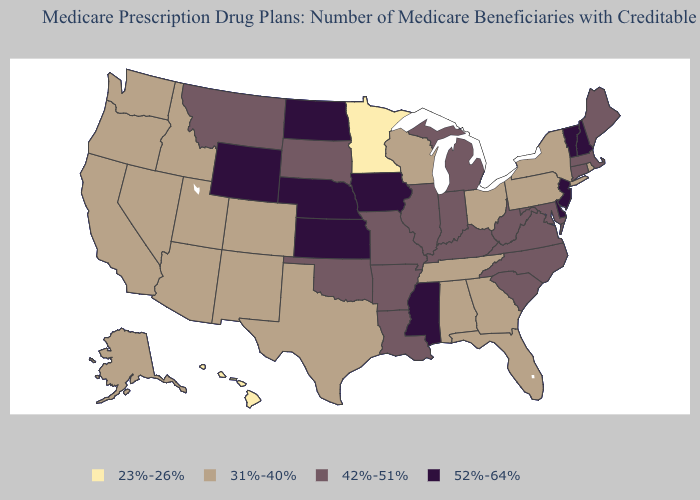Among the states that border Wisconsin , does Illinois have the highest value?
Short answer required. No. Does Michigan have the same value as Colorado?
Answer briefly. No. Name the states that have a value in the range 31%-40%?
Write a very short answer. Alabama, Alaska, Arizona, California, Colorado, Florida, Georgia, Idaho, Nevada, New Mexico, New York, Ohio, Oregon, Pennsylvania, Rhode Island, Tennessee, Texas, Utah, Washington, Wisconsin. Name the states that have a value in the range 42%-51%?
Give a very brief answer. Arkansas, Connecticut, Illinois, Indiana, Kentucky, Louisiana, Maine, Maryland, Massachusetts, Michigan, Missouri, Montana, North Carolina, Oklahoma, South Carolina, South Dakota, Virginia, West Virginia. Does Louisiana have the same value as Wyoming?
Give a very brief answer. No. Name the states that have a value in the range 42%-51%?
Be succinct. Arkansas, Connecticut, Illinois, Indiana, Kentucky, Louisiana, Maine, Maryland, Massachusetts, Michigan, Missouri, Montana, North Carolina, Oklahoma, South Carolina, South Dakota, Virginia, West Virginia. What is the value of New York?
Be succinct. 31%-40%. Among the states that border Ohio , which have the highest value?
Answer briefly. Indiana, Kentucky, Michigan, West Virginia. Does New York have the lowest value in the Northeast?
Answer briefly. Yes. How many symbols are there in the legend?
Quick response, please. 4. What is the value of North Dakota?
Write a very short answer. 52%-64%. How many symbols are there in the legend?
Give a very brief answer. 4. Name the states that have a value in the range 42%-51%?
Answer briefly. Arkansas, Connecticut, Illinois, Indiana, Kentucky, Louisiana, Maine, Maryland, Massachusetts, Michigan, Missouri, Montana, North Carolina, Oklahoma, South Carolina, South Dakota, Virginia, West Virginia. Does the first symbol in the legend represent the smallest category?
Quick response, please. Yes. Name the states that have a value in the range 31%-40%?
Concise answer only. Alabama, Alaska, Arizona, California, Colorado, Florida, Georgia, Idaho, Nevada, New Mexico, New York, Ohio, Oregon, Pennsylvania, Rhode Island, Tennessee, Texas, Utah, Washington, Wisconsin. 